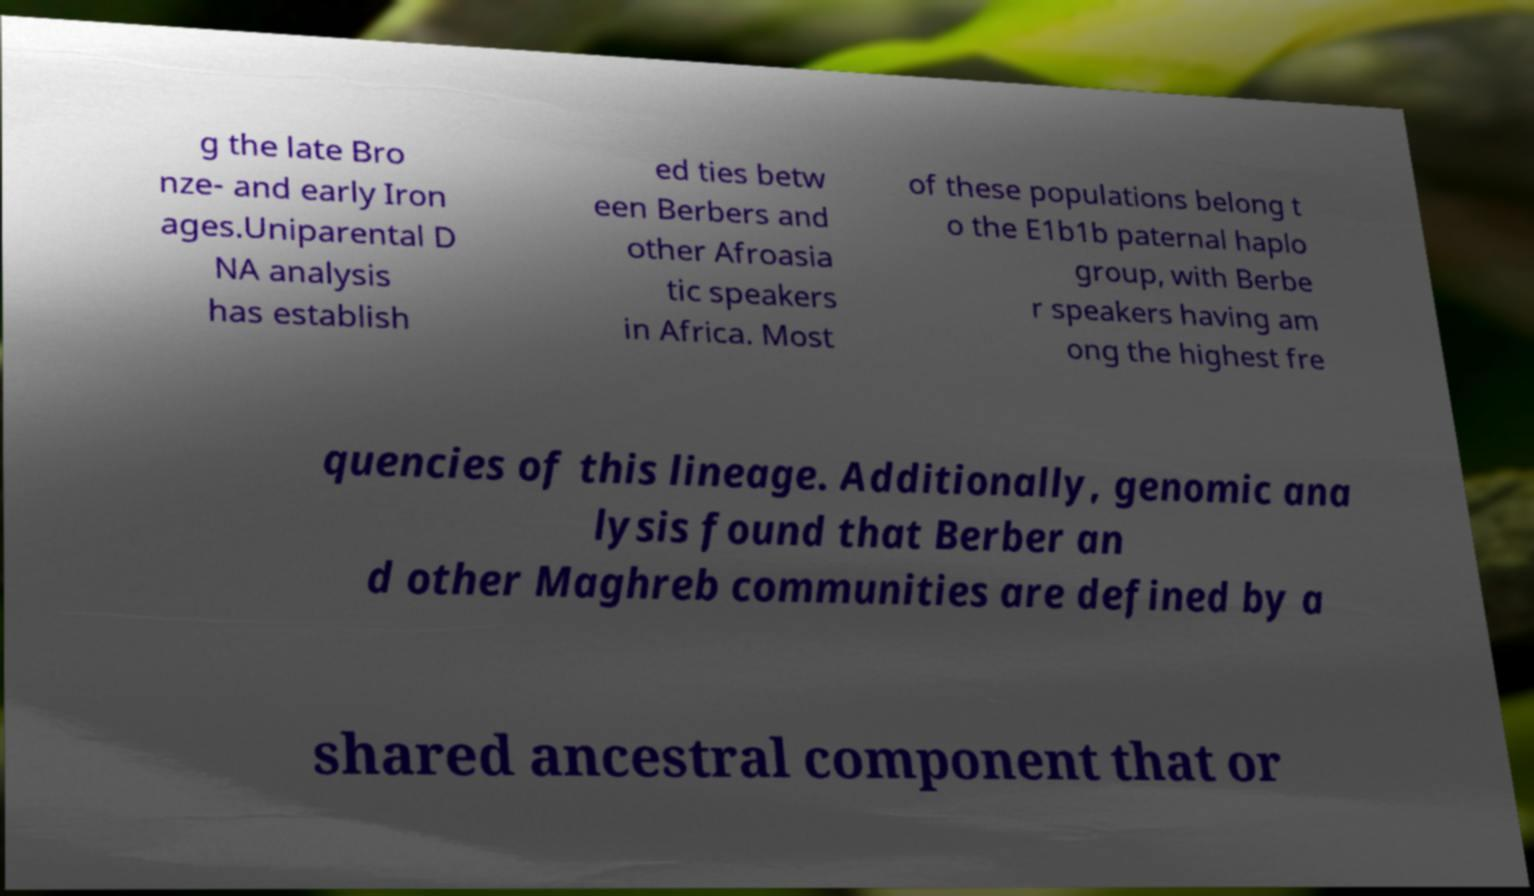Could you extract and type out the text from this image? g the late Bro nze- and early Iron ages.Uniparental D NA analysis has establish ed ties betw een Berbers and other Afroasia tic speakers in Africa. Most of these populations belong t o the E1b1b paternal haplo group, with Berbe r speakers having am ong the highest fre quencies of this lineage. Additionally, genomic ana lysis found that Berber an d other Maghreb communities are defined by a shared ancestral component that or 